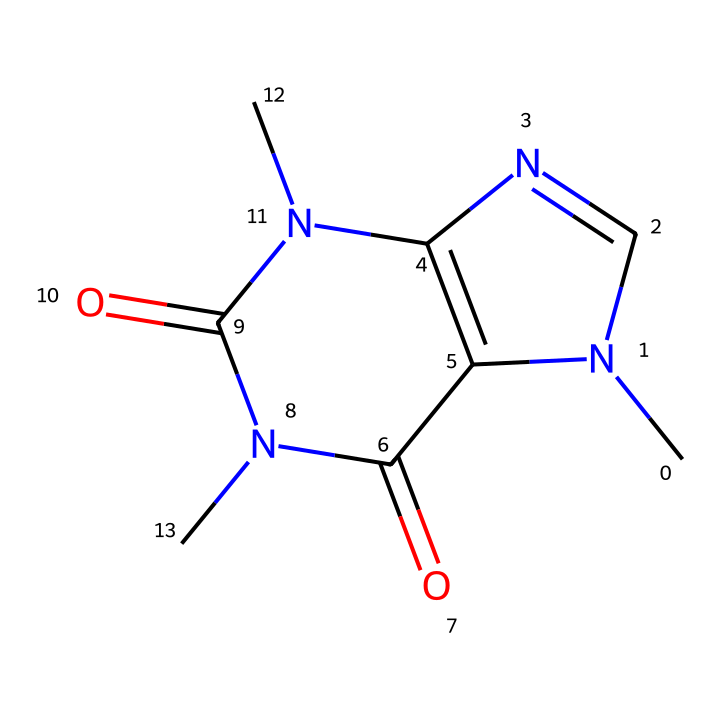What is the molecular formula of caffeine? To determine the molecular formula, we need to count the different atoms in the SMILES representation, which includes carbon (C), nitrogen (N), and oxygen (O). There are 8 carbon atoms, 10 hydrogen atoms, 4 nitrogen atoms, and 2 oxygen atoms, leading to the formula C8H10N4O2.
Answer: C8H10N4O2 How many rings are present in the structure of caffeine? By examining the SMILES, we can identify two distinct ring systems formed around the nitrogen and carbon atoms. The notation indicates that there are two ring structures within the molecule.
Answer: 2 What type of chemical is caffeine classified as? Caffeine is classified as an alkaloid due to its nitrogen-containing structure and biological activity. The presence of multiple nitrogen atoms indicates its alkaloid nature.
Answer: alkaloid What is the total number of nitrogen atoms in caffeine? In the SMILES string, we can see there are 4 occurrences of nitrogen (N) atoms. Counting these gives us the total number of nitrogen atoms present in caffeine.
Answer: 4 Which part of the caffeine structure contributes to its solubility in non-polar solvents? The methyl groups (the -CH3 portions attached to the nitrogen atoms) are primarily responsible for its solubility in non-polar solvents because they exhibit hydrophobic characteristics.
Answer: methyl groups Why is caffeine considered a non-electrolyte? Caffeine does not dissociate into ions in solution, as indicated by its stable covalent structure. This non-ionization confirms its classification as a non-electrolyte.
Answer: non-ionizing 